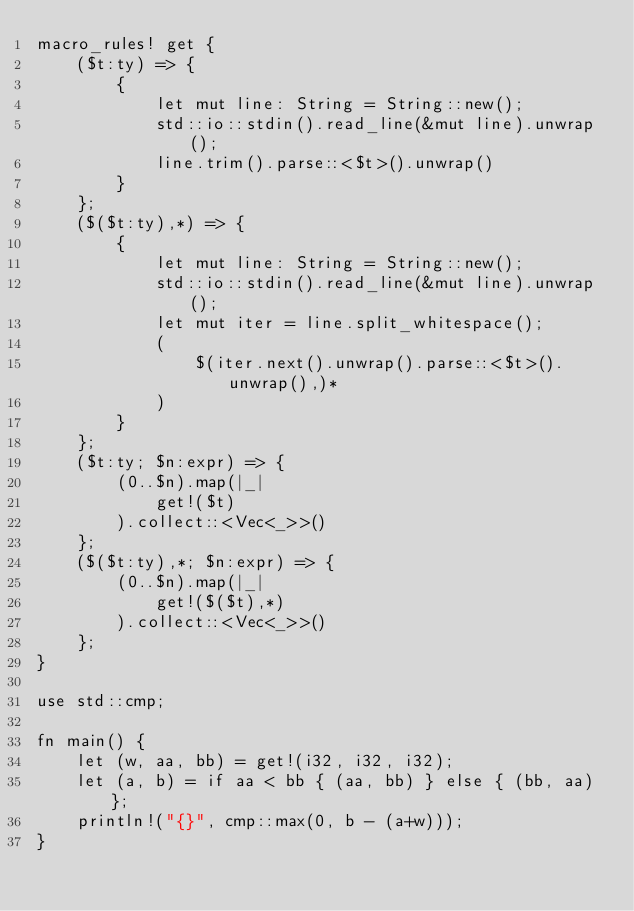Convert code to text. <code><loc_0><loc_0><loc_500><loc_500><_Rust_>macro_rules! get {
    ($t:ty) => {
        {
            let mut line: String = String::new();
            std::io::stdin().read_line(&mut line).unwrap();
            line.trim().parse::<$t>().unwrap()
        }
    };
    ($($t:ty),*) => {
        {
            let mut line: String = String::new();
            std::io::stdin().read_line(&mut line).unwrap();
            let mut iter = line.split_whitespace();
            (
                $(iter.next().unwrap().parse::<$t>().unwrap(),)*
            )
        }
    };
    ($t:ty; $n:expr) => {
        (0..$n).map(|_|
            get!($t)
        ).collect::<Vec<_>>()
    };
    ($($t:ty),*; $n:expr) => {
        (0..$n).map(|_|
            get!($($t),*)
        ).collect::<Vec<_>>()
    };
}

use std::cmp;

fn main() {
    let (w, aa, bb) = get!(i32, i32, i32);
    let (a, b) = if aa < bb { (aa, bb) } else { (bb, aa) };
    println!("{}", cmp::max(0, b - (a+w)));
}</code> 